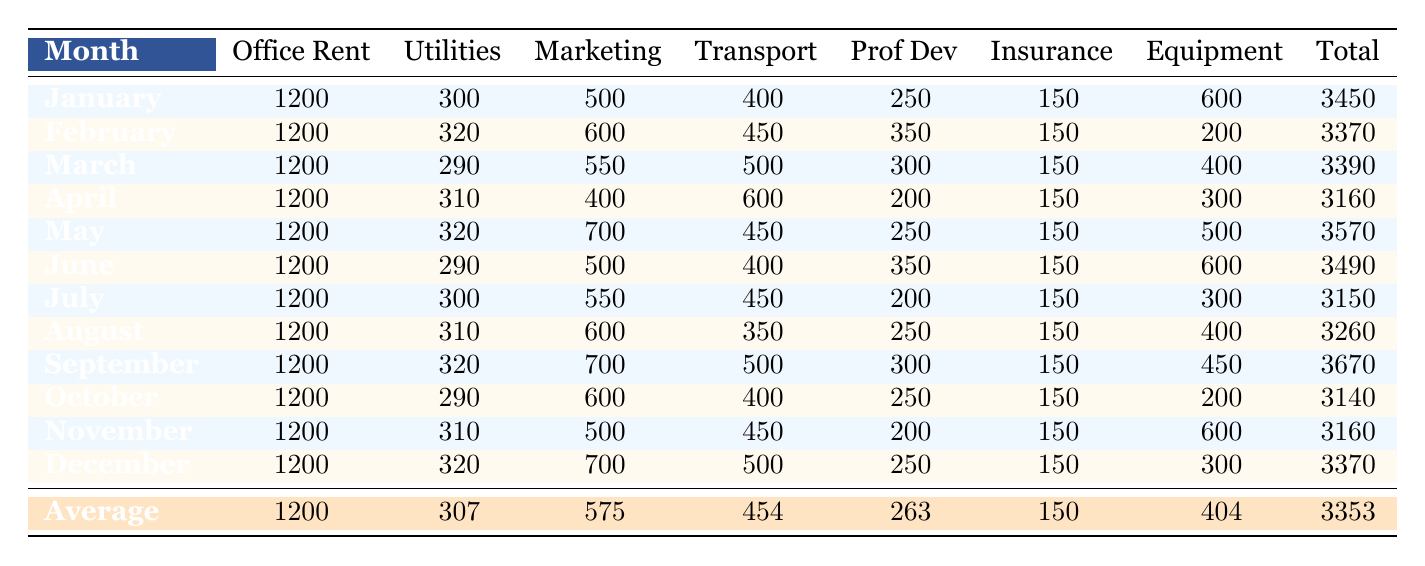What is the total expense for March? The table indicates that the total expense for March is listed directly in the total column, which shows 3390.
Answer: 3390 What was the highest marketing expense in a month? Looking at the marketing expenses for each month, I see that September has the highest value listed at 700.
Answer: 700 How much did office rent total for the year? Since the office rent is constant at 1200 each month across 12 months, I calculate the total by multiplying 1200 by 12, resulting in 14400.
Answer: 14400 Which month had the lowest total expenses? By reviewing the total expenses for each month, I find that April has the lowest total, which is 3160.
Answer: 3160 What is the average transportation expense throughout the year? To find the average, I sum the transportation costs: (400 + 450 + 500 + 600 + 450 + 400 + 450 + 350 + 500 + 400 + 450 + 500) = 5400, and then divide by 12 months, resulting in 450.
Answer: 450 Was the insurance expense the same across all months? Yes, the insurance expense is consistently listed as 150 for every month throughout the year according to the table.
Answer: Yes What was the difference between the highest and lowest total expenses in a month? The highest total expense was in September at 3670, and the lowest was in April at 3160. The difference is 3670 - 3160 = 510.
Answer: 510 In which month did the expenses exceed the annual average? The table shows the average total expense for the year as 3353. The months exceeding this are May (3570), June (3490), September (3670), and December (3370).
Answer: May, June, September, December How much was spent on professional development in total throughout the year? I sum the professional development expenses from each month: (250 + 350 + 300 + 200 + 250 + 350 + 200 + 250 + 300 + 250 + 200 + 250) = 3050.
Answer: 3050 Which month's total expense was closest to the average yearly total? The average total is 3353. The month closest to this is December with a total of 3370, only 17 higher.
Answer: December 